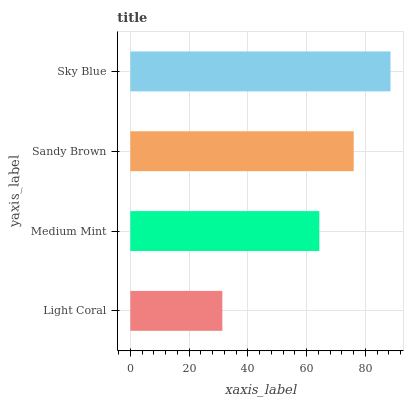Is Light Coral the minimum?
Answer yes or no. Yes. Is Sky Blue the maximum?
Answer yes or no. Yes. Is Medium Mint the minimum?
Answer yes or no. No. Is Medium Mint the maximum?
Answer yes or no. No. Is Medium Mint greater than Light Coral?
Answer yes or no. Yes. Is Light Coral less than Medium Mint?
Answer yes or no. Yes. Is Light Coral greater than Medium Mint?
Answer yes or no. No. Is Medium Mint less than Light Coral?
Answer yes or no. No. Is Sandy Brown the high median?
Answer yes or no. Yes. Is Medium Mint the low median?
Answer yes or no. Yes. Is Sky Blue the high median?
Answer yes or no. No. Is Sandy Brown the low median?
Answer yes or no. No. 